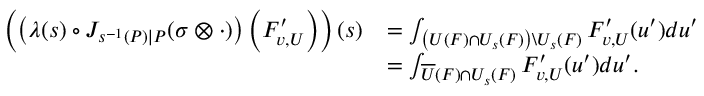<formula> <loc_0><loc_0><loc_500><loc_500>\begin{array} { r l } { \left ( \left ( \lambda ( s ) \circ J _ { s ^ { - 1 } ( P ) | P } ( \sigma \otimes \cdot ) \right ) \left ( F _ { v , U } ^ { \prime } \right ) \right ) ( s ) } & { = \int _ { \left ( U ( F ) \cap U _ { s } ( F ) \right ) \ U _ { s } ( F ) } F _ { v , U } ^ { \prime } ( u ^ { \prime } ) d u ^ { \prime } } \\ & { = \int _ { \overline { U } ( F ) \cap U _ { s } ( F ) } F _ { v , U } ^ { \prime } ( u ^ { \prime } ) d u ^ { \prime } . } \end{array}</formula> 